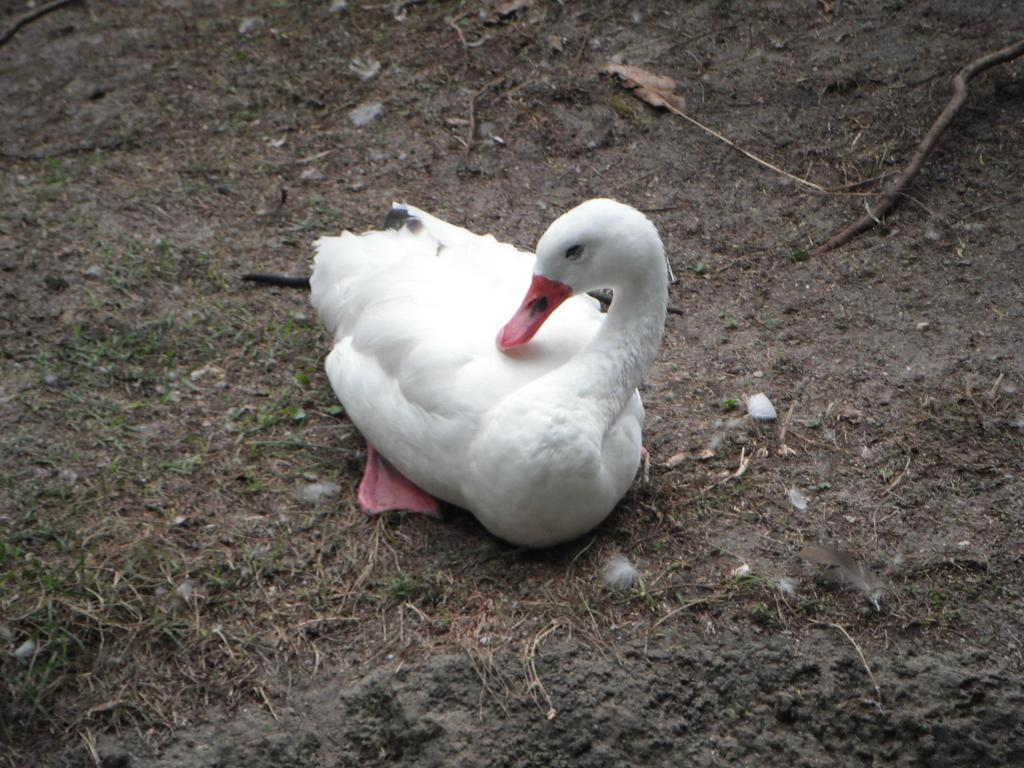What type of animal is in the image? There is a white-colored duck in the image. Where is the duck located in the image? The duck is on the ground. What type of development is the duck undergoing in the image? There is no indication of any development occurring to the duck in the image. 